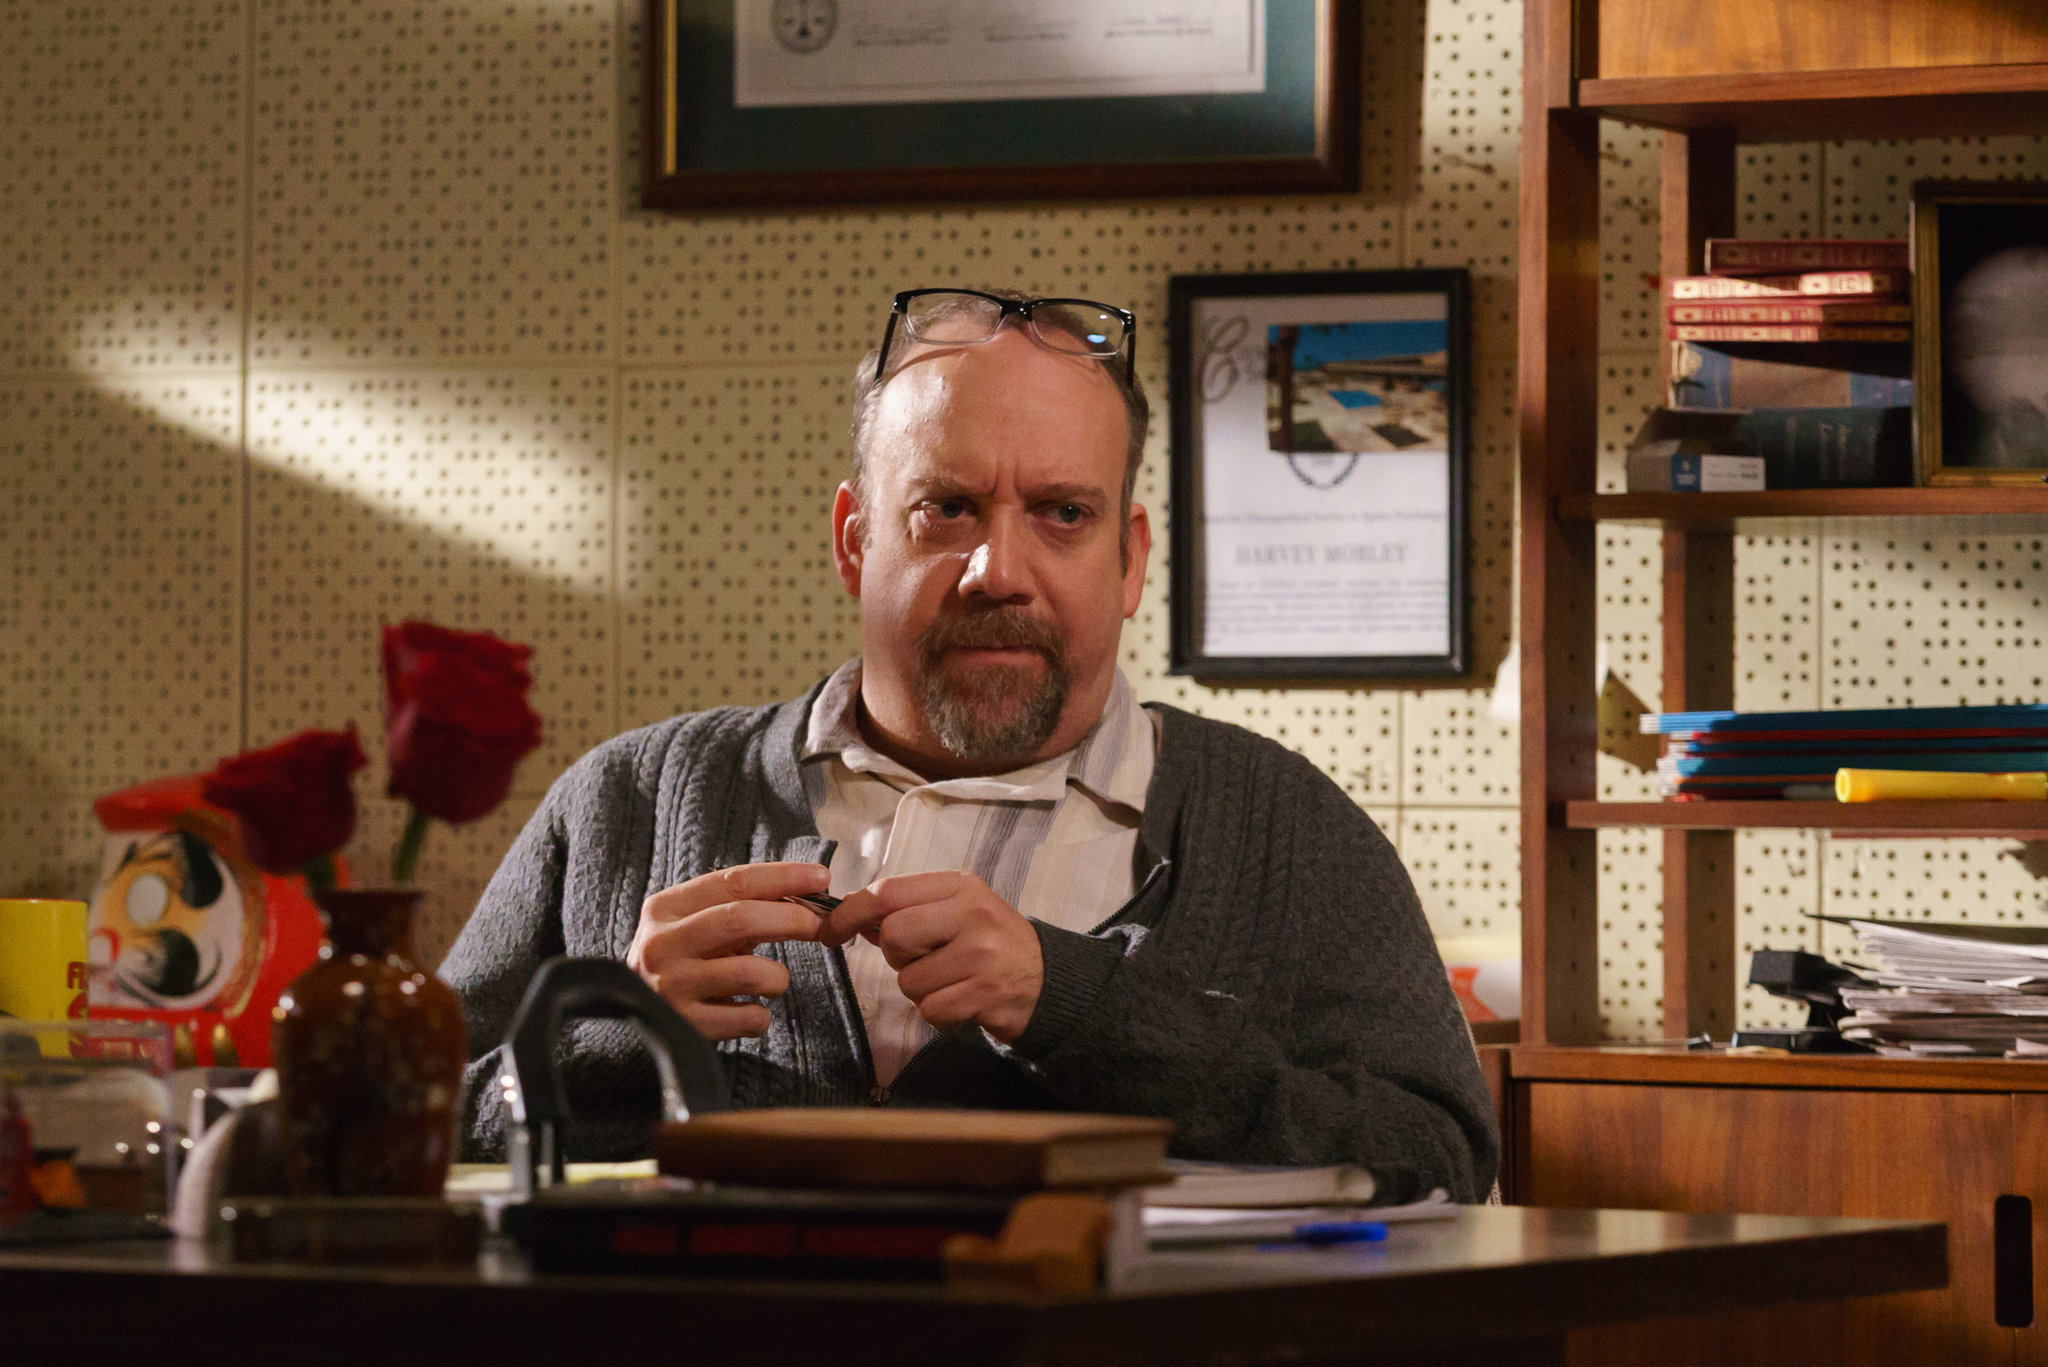Is there any significance to the single rose placed on the desk? The single rose placed on the desk adds a symbolic touch to the image. It could represent a personal sentiment, such as a reminder of a loved one or a special occasion. Alternatively, it might simply serve as a decorative element that brings a bit of nature and beauty into a bustling work environment. The rose interacts with the surroundings to create a more nuanced and emotionally resonant workspace. 